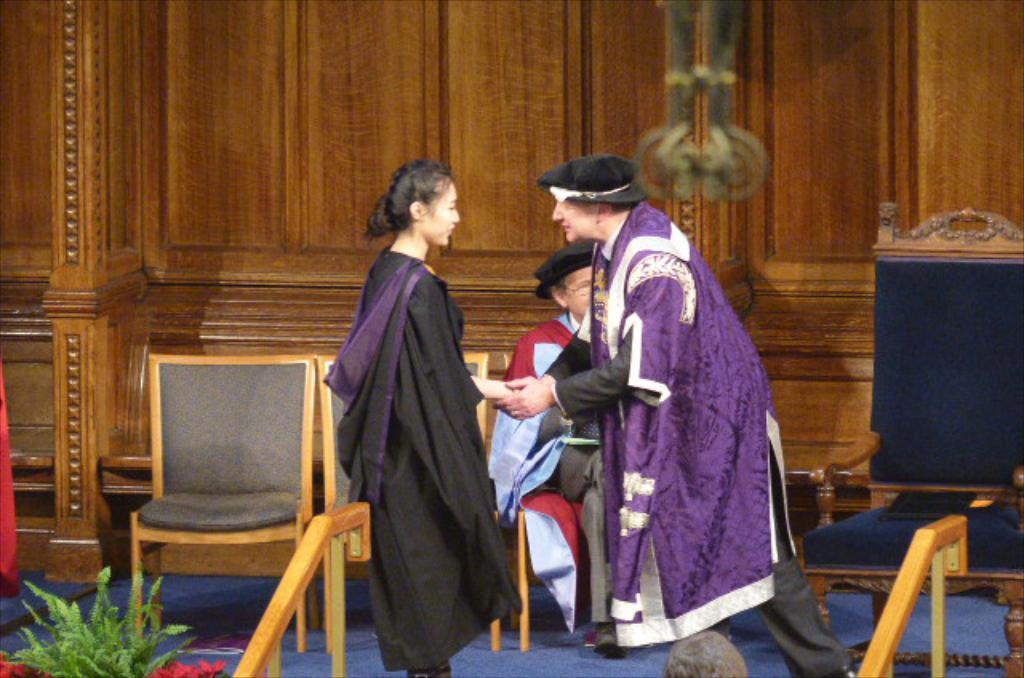Could you give a brief overview of what you see in this image? There are 3 people on the stage and also chairs and a houseplant. 